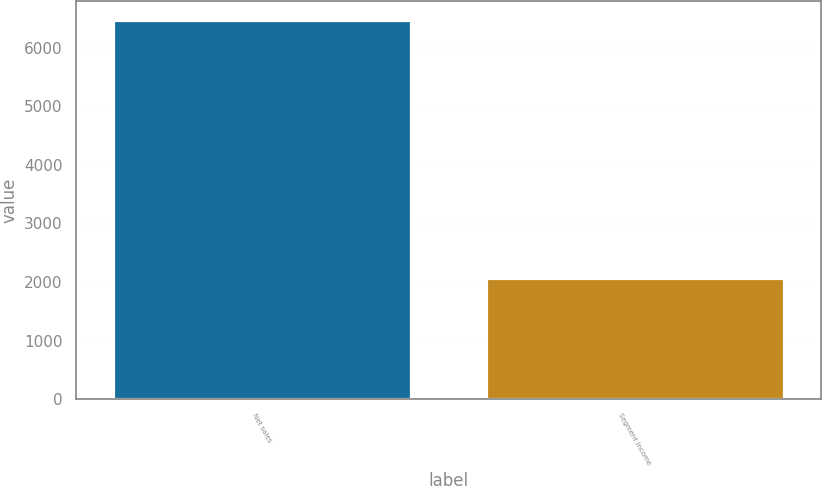Convert chart to OTSL. <chart><loc_0><loc_0><loc_500><loc_500><bar_chart><fcel>Net sales<fcel>Segment income<nl><fcel>6468.1<fcel>2074<nl></chart> 